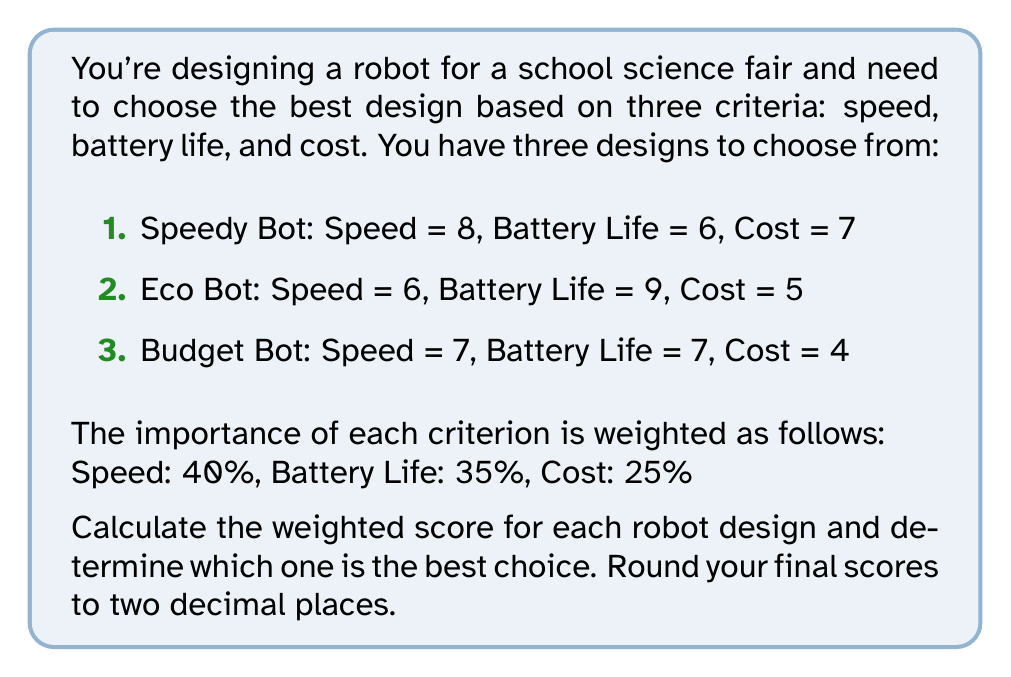Help me with this question. To solve this problem, we'll follow these steps:

1. Normalize the scores for each criterion to a scale of 0-1.
2. Calculate the weighted score for each robot design.
3. Compare the final scores to determine the best design.

Step 1: Normalize the scores

For each criterion, divide each robot's score by the highest score in that category:

Speed:
Speedy Bot: $\frac{8}{8} = 1$
Eco Bot: $\frac{6}{8} = 0.75$
Budget Bot: $\frac{7}{8} = 0.875$

Battery Life:
Speedy Bot: $\frac{6}{9} = 0.667$
Eco Bot: $\frac{9}{9} = 1$
Budget Bot: $\frac{7}{9} = 0.778$

Cost (lower is better, so we invert the scores):
Speedy Bot: $\frac{4}{7} = 0.571$
Eco Bot: $\frac{4}{5} = 0.8$
Budget Bot: $\frac{4}{4} = 1$

Step 2: Calculate weighted scores

For each robot, multiply the normalized score by the weight for each criterion and sum the results:

Speedy Bot:
$$(1 \times 0.40) + (0.667 \times 0.35) + (0.571 \times 0.25) = 0.40 + 0.233 + 0.143 = 0.776$$

Eco Bot:
$$(0.75 \times 0.40) + (1 \times 0.35) + (0.8 \times 0.25) = 0.30 + 0.35 + 0.20 = 0.85$$

Budget Bot:
$$(0.875 \times 0.40) + (0.778 \times 0.35) + (1 \times 0.25) = 0.35 + 0.272 + 0.25 = 0.872$$

Step 3: Compare final scores

Rounding to two decimal places:
Speedy Bot: 0.78
Eco Bot: 0.85
Budget Bot: 0.87

The Budget Bot has the highest score, making it the best choice based on the given criteria and weights.
Answer: The best robot design is the Budget Bot with a weighted score of 0.87. 